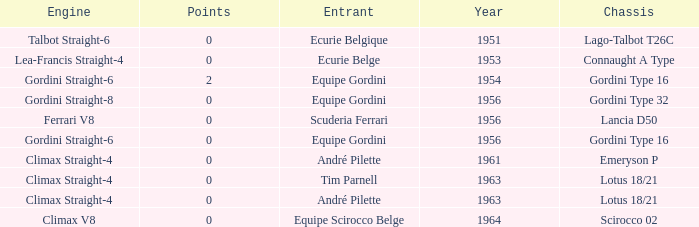Who used Gordini Straight-6 in 1956? Equipe Gordini. 